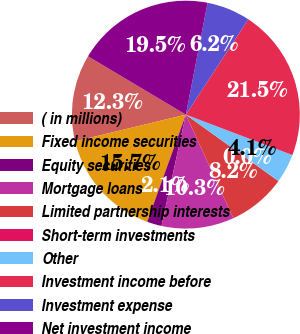<chart> <loc_0><loc_0><loc_500><loc_500><pie_chart><fcel>( in millions)<fcel>Fixed income securities<fcel>Equity securities<fcel>Mortgage loans<fcel>Limited partnership interests<fcel>Short-term investments<fcel>Other<fcel>Investment income before<fcel>Investment expense<fcel>Net investment income<nl><fcel>12.32%<fcel>15.72%<fcel>2.08%<fcel>10.28%<fcel>8.23%<fcel>0.03%<fcel>4.13%<fcel>21.54%<fcel>6.18%<fcel>19.5%<nl></chart> 